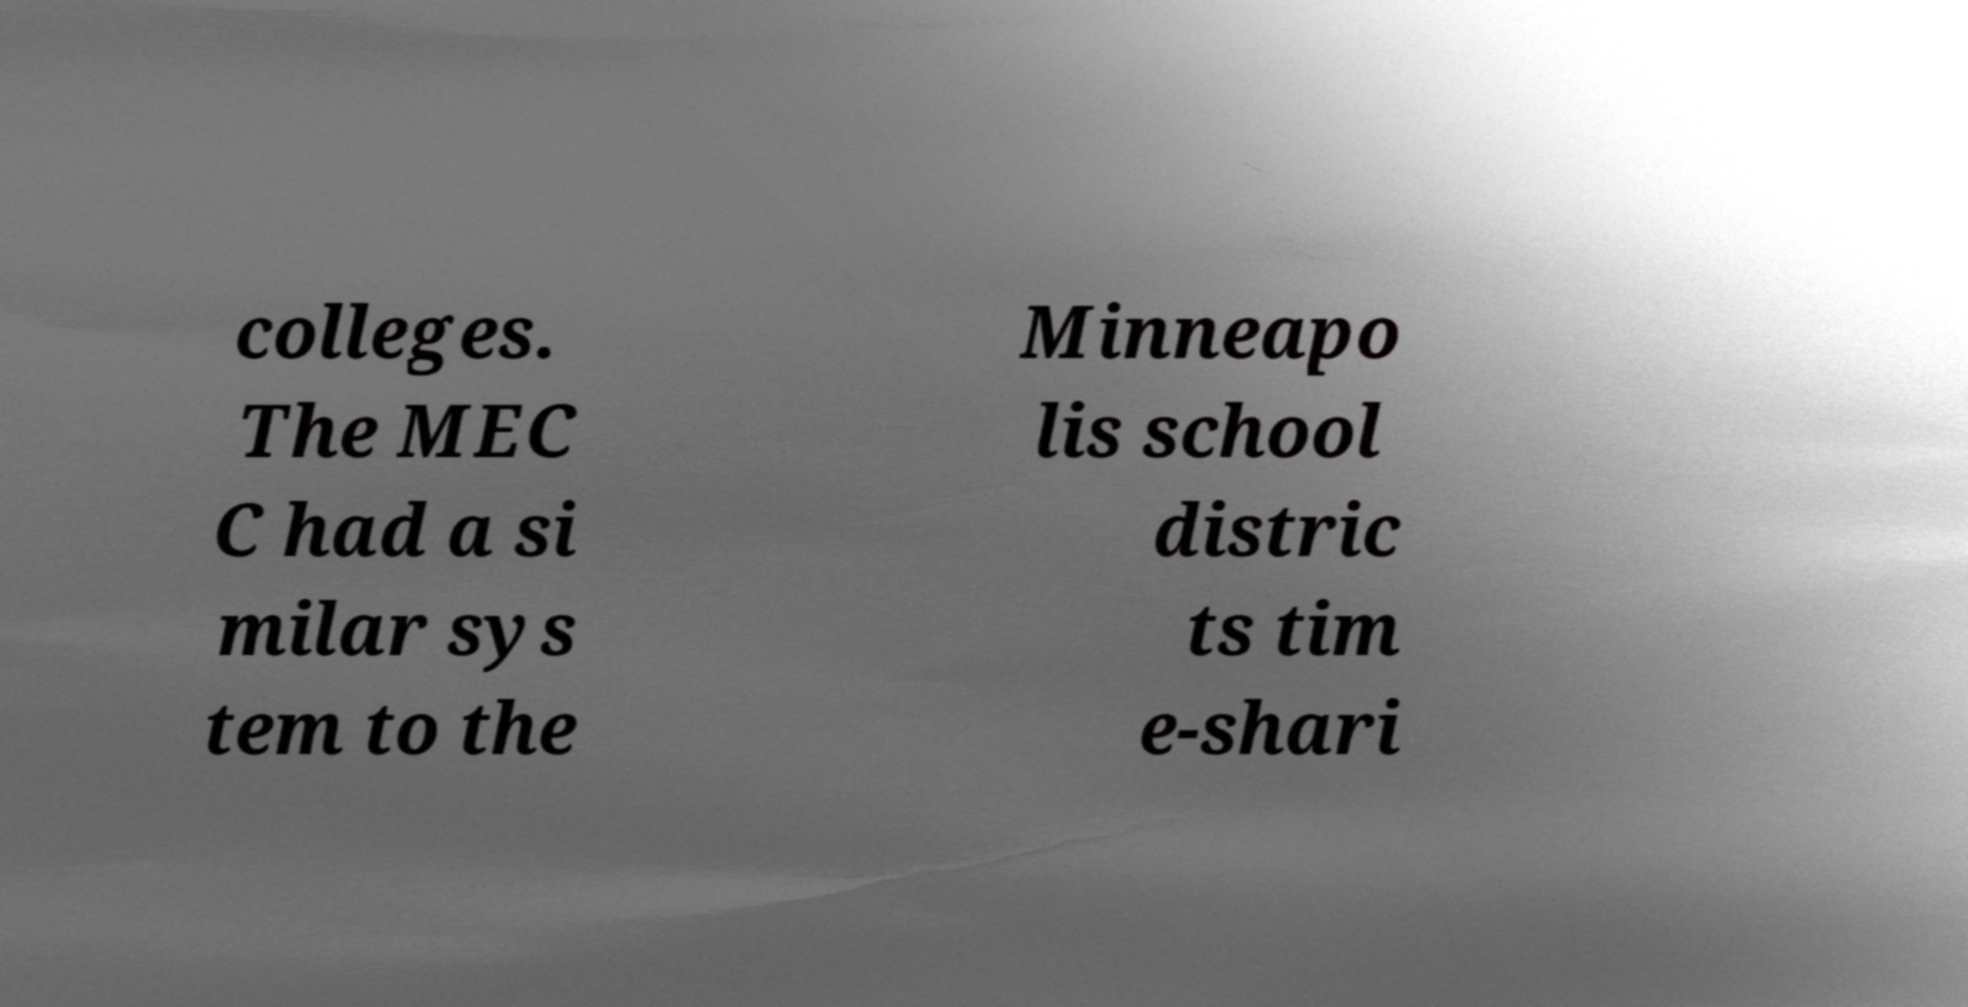Could you assist in decoding the text presented in this image and type it out clearly? colleges. The MEC C had a si milar sys tem to the Minneapo lis school distric ts tim e-shari 